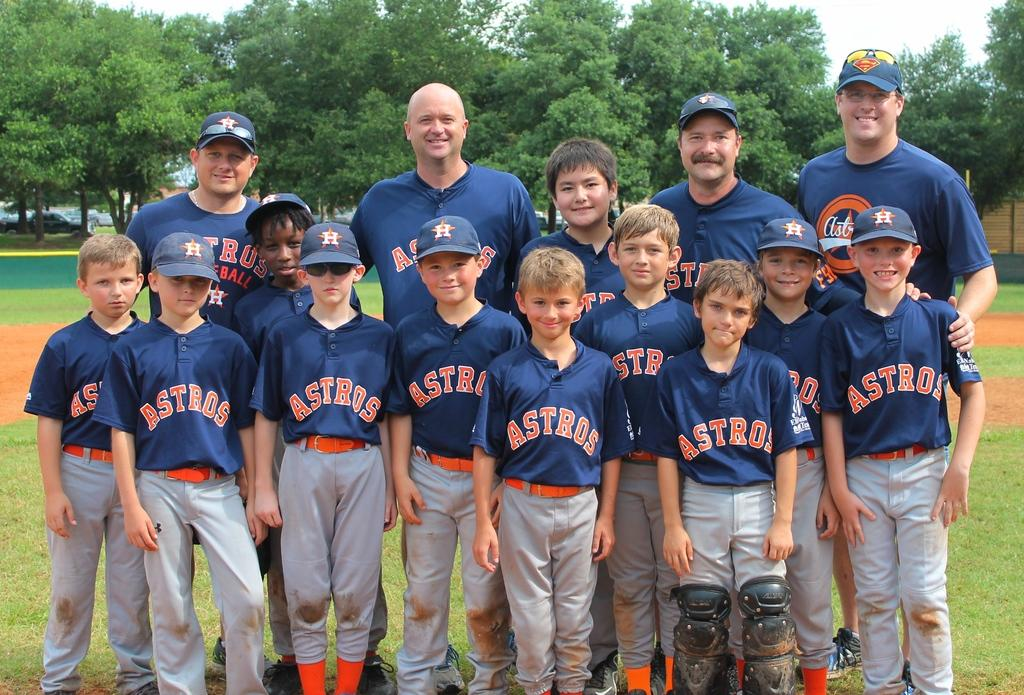<image>
Present a compact description of the photo's key features. A team stands together with Astros uniforms on. 